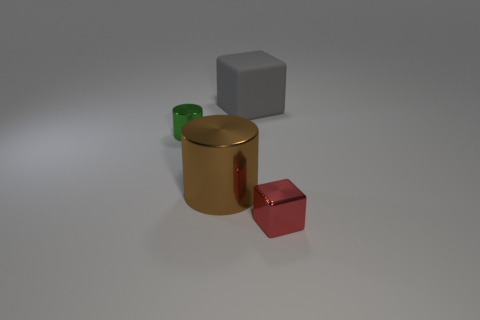Can you describe the textures present in the objects? Certainly! The red and golden objects have a smooth and reflective texture, indicative of polished metal. The gray cube appears to have a matte finish, which could suggest a plastic or non-glossy metallic material. The surface beneath the objects is also matte and slightly textured, which contrasts with the shiny finish of the red and golden items. 